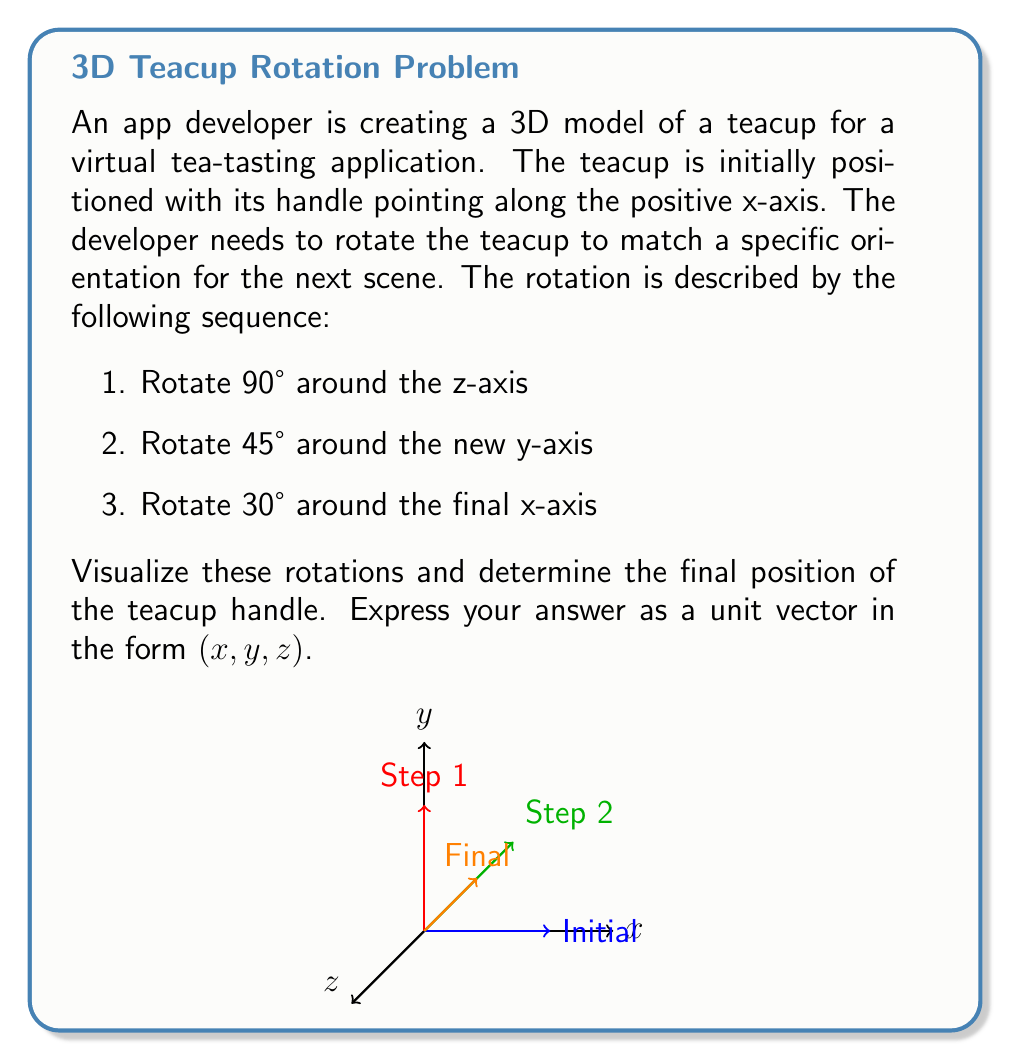Provide a solution to this math problem. Let's break down the rotations step-by-step:

1. Initial position: The handle points along the positive x-axis, represented by the vector (1, 0, 0).

2. First rotation: 90° around the z-axis
   This moves the handle to point along the positive y-axis: (0, 1, 0)
   
   Rotation matrix: 
   $$R_z(90°) = \begin{pmatrix}
   0 & -1 & 0 \\
   1 & 0 & 0 \\
   0 & 0 & 1
   \end{pmatrix}$$

3. Second rotation: 45° around the new y-axis
   This rotates the handle in the xz-plane:
   $(\frac{1}{\sqrt{2}}, 1, \frac{1}{\sqrt{2}})$
   
   Rotation matrix:
   $$R_y(45°) = \begin{pmatrix}
   \cos 45° & 0 & \sin 45° \\
   0 & 1 & 0 \\
   -\sin 45° & 0 & \cos 45°
   \end{pmatrix} = \begin{pmatrix}
   \frac{1}{\sqrt{2}} & 0 & \frac{1}{\sqrt{2}} \\
   0 & 1 & 0 \\
   -\frac{1}{\sqrt{2}} & 0 & \frac{1}{\sqrt{2}}
   \end{pmatrix}$$

4. Final rotation: 30° around the final x-axis
   This rotates the handle in the yz-plane:
   $(\frac{1}{\sqrt{2}}, \frac{\sqrt{3}}{2}, \frac{1}{2})$
   
   Rotation matrix:
   $$R_x(30°) = \begin{pmatrix}
   1 & 0 & 0 \\
   0 & \cos 30° & -\sin 30° \\
   0 & \sin 30° & \cos 30°
   \end{pmatrix} = \begin{pmatrix}
   1 & 0 & 0 \\
   0 & \frac{\sqrt{3}}{2} & -\frac{1}{2} \\
   0 & \frac{1}{2} & \frac{\sqrt{3}}{2}
   \end{pmatrix}$$

The final position is the result of applying these rotations in sequence:
$$\vec{v}_{\text{final}} = R_x(30°) \cdot R_y(45°) \cdot R_z(90°) \cdot (1, 0, 0)$$

Calculating this gives us the vector $(\frac{1}{\sqrt{2}}, \frac{\sqrt{3}}{2}, \frac{1}{2})$.

To verify that this is a unit vector:
$$\sqrt{(\frac{1}{\sqrt{2}})^2 + (\frac{\sqrt{3}}{2})^2 + (\frac{1}{2})^2} = \sqrt{\frac{1}{2} + \frac{3}{4} + \frac{1}{4}} = \sqrt{1} = 1$$
Answer: $(\frac{1}{\sqrt{2}}, \frac{\sqrt{3}}{2}, \frac{1}{2})$ 